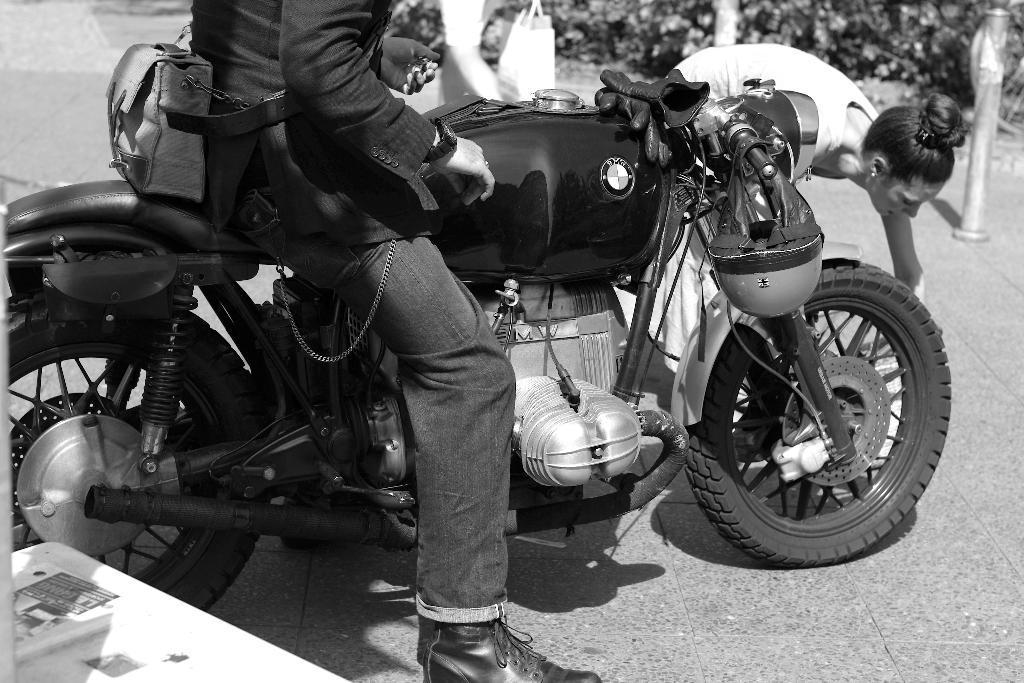What is the person in the image doing? The person is sitting on a motorcycle in the image. Can you describe the woman in the image? The woman is in the image and she is picking something from the ground. What type of creature can be seen walking in the snow in the image? There is no creature or snow present in the image; it features a person on a motorcycle and a woman picking something from the ground. Is there a church visible in the image? There is no church present in the image. 